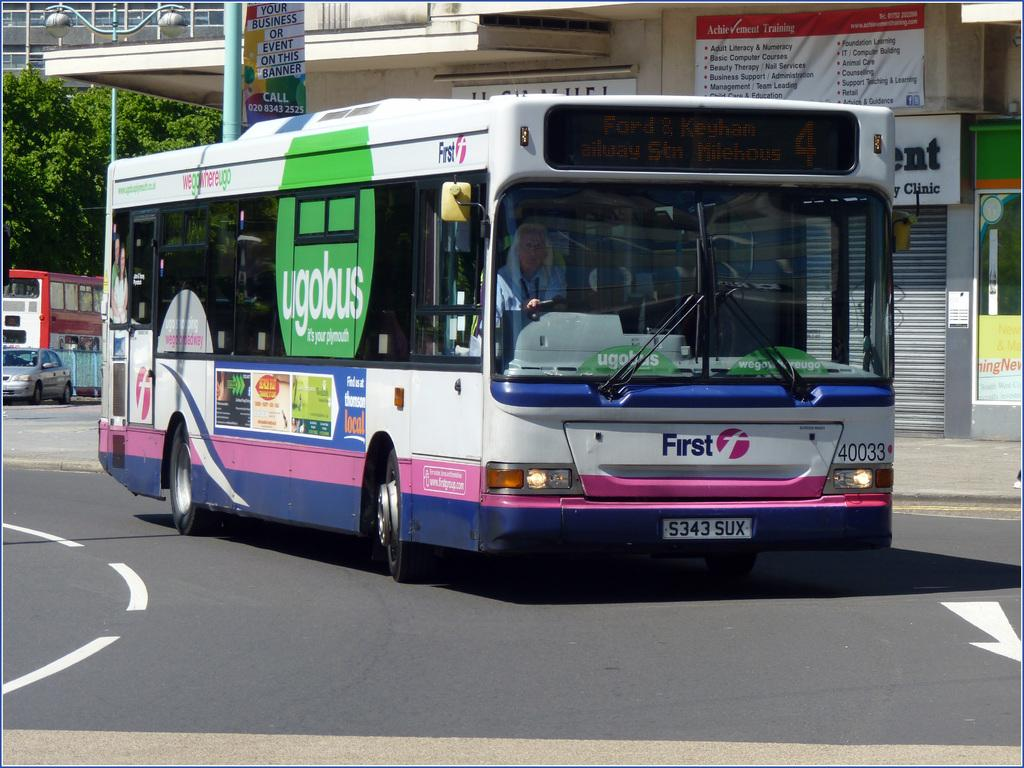<image>
Relay a brief, clear account of the picture shown. A bus that says ugobus on the side of the bus and First on the front of the bus which is on a street. 